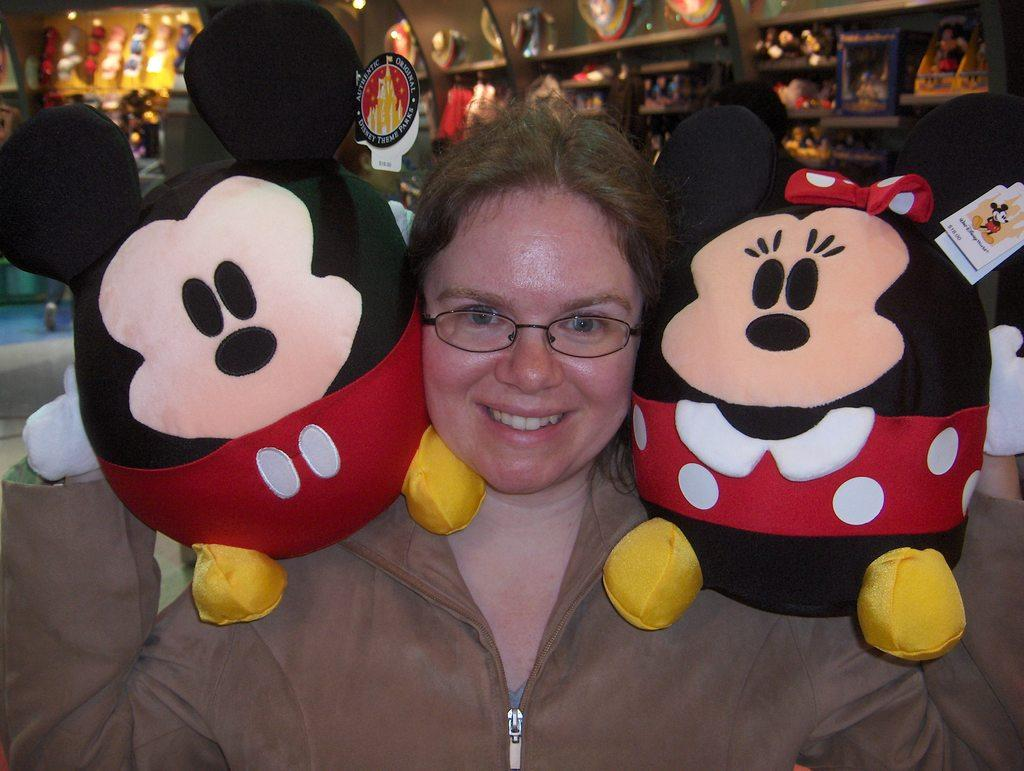What is the woman holding in the image? The woman is holding toys in the image. Can you describe the arrangement of toys or objects in the image? There are toys or objects arranged in racks in the image. What type of crime is being committed in the image? There is no indication of any crime being committed in the image; the image features a woman holding toys and toys arranged in racks in the background. 